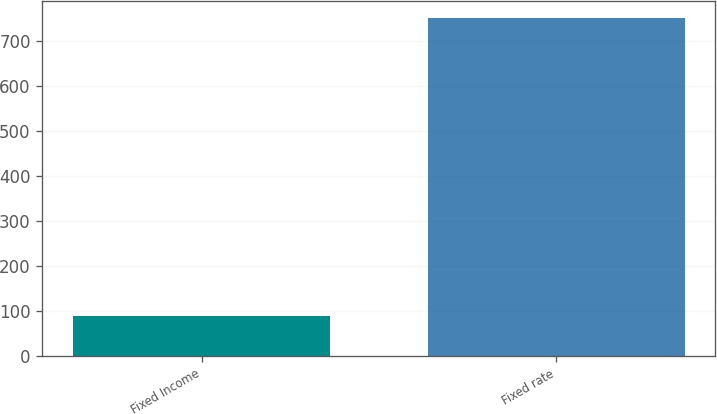Convert chart. <chart><loc_0><loc_0><loc_500><loc_500><bar_chart><fcel>Fixed Income<fcel>Fixed rate<nl><fcel>89<fcel>751<nl></chart> 